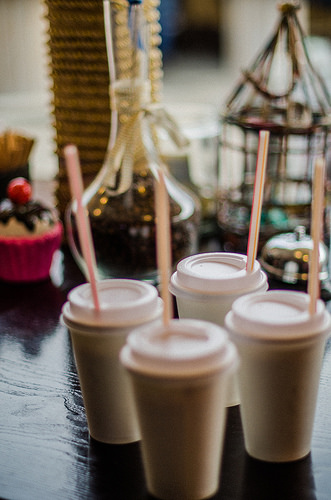<image>
Is there a cup on the table? Yes. Looking at the image, I can see the cup is positioned on top of the table, with the table providing support. Is there a cup behind the cup? Yes. From this viewpoint, the cup is positioned behind the cup, with the cup partially or fully occluding the cup. Is the bell in front of the cup? No. The bell is not in front of the cup. The spatial positioning shows a different relationship between these objects. 